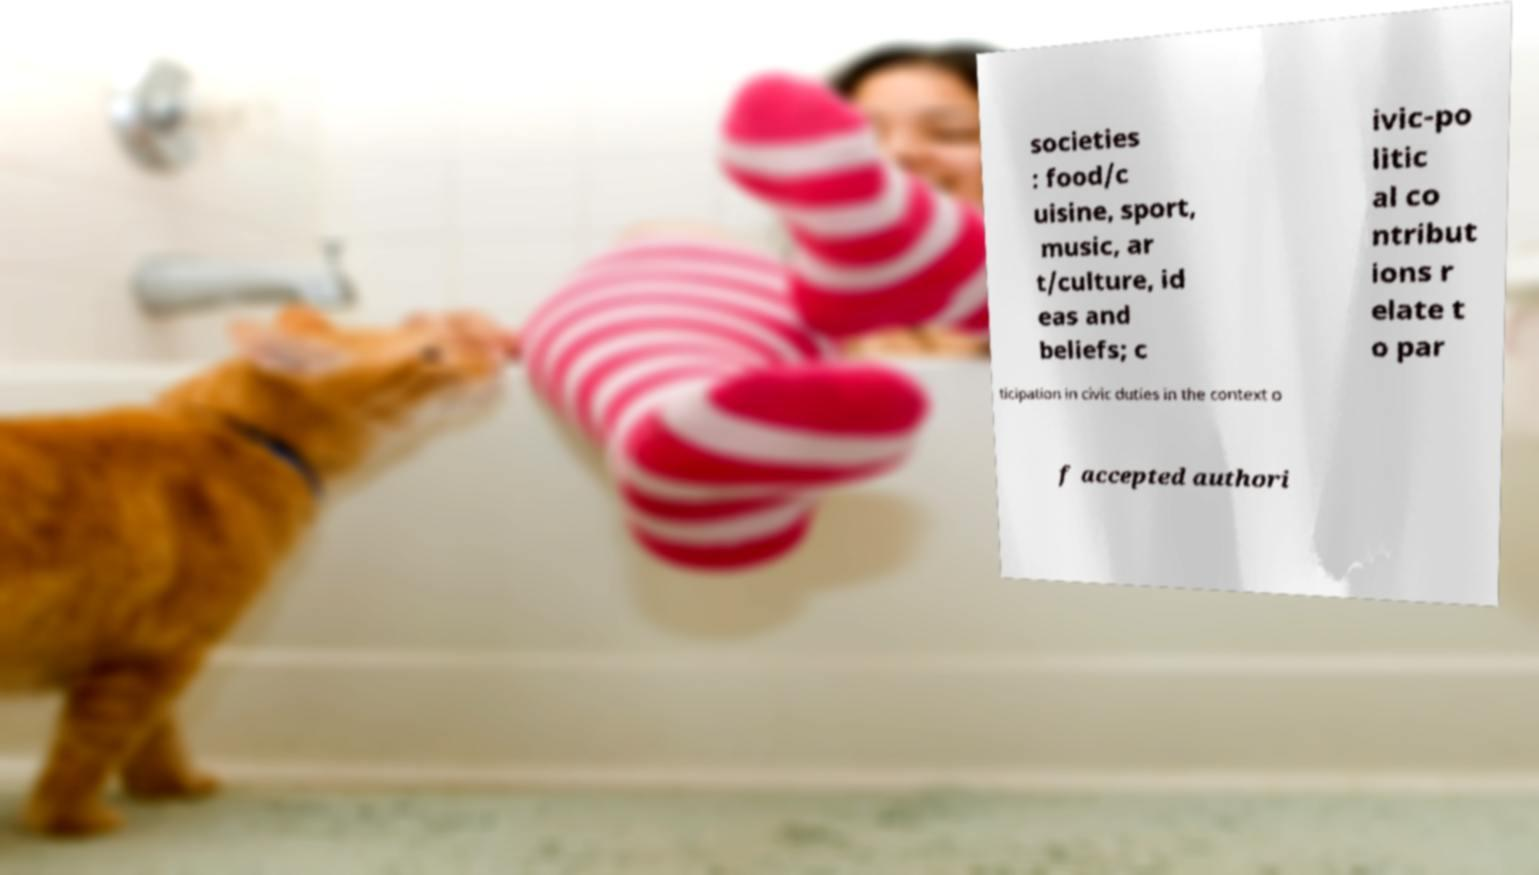Can you read and provide the text displayed in the image?This photo seems to have some interesting text. Can you extract and type it out for me? societies : food/c uisine, sport, music, ar t/culture, id eas and beliefs; c ivic-po litic al co ntribut ions r elate t o par ticipation in civic duties in the context o f accepted authori 